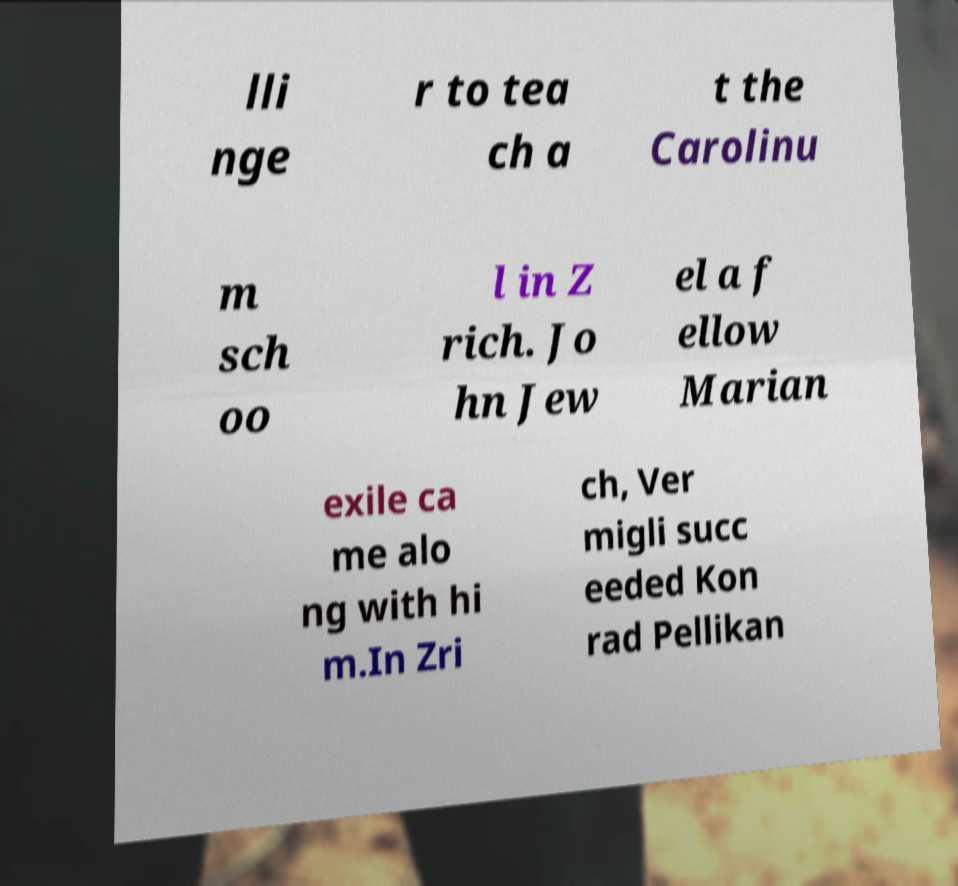Please identify and transcribe the text found in this image. lli nge r to tea ch a t the Carolinu m sch oo l in Z rich. Jo hn Jew el a f ellow Marian exile ca me alo ng with hi m.In Zri ch, Ver migli succ eeded Kon rad Pellikan 